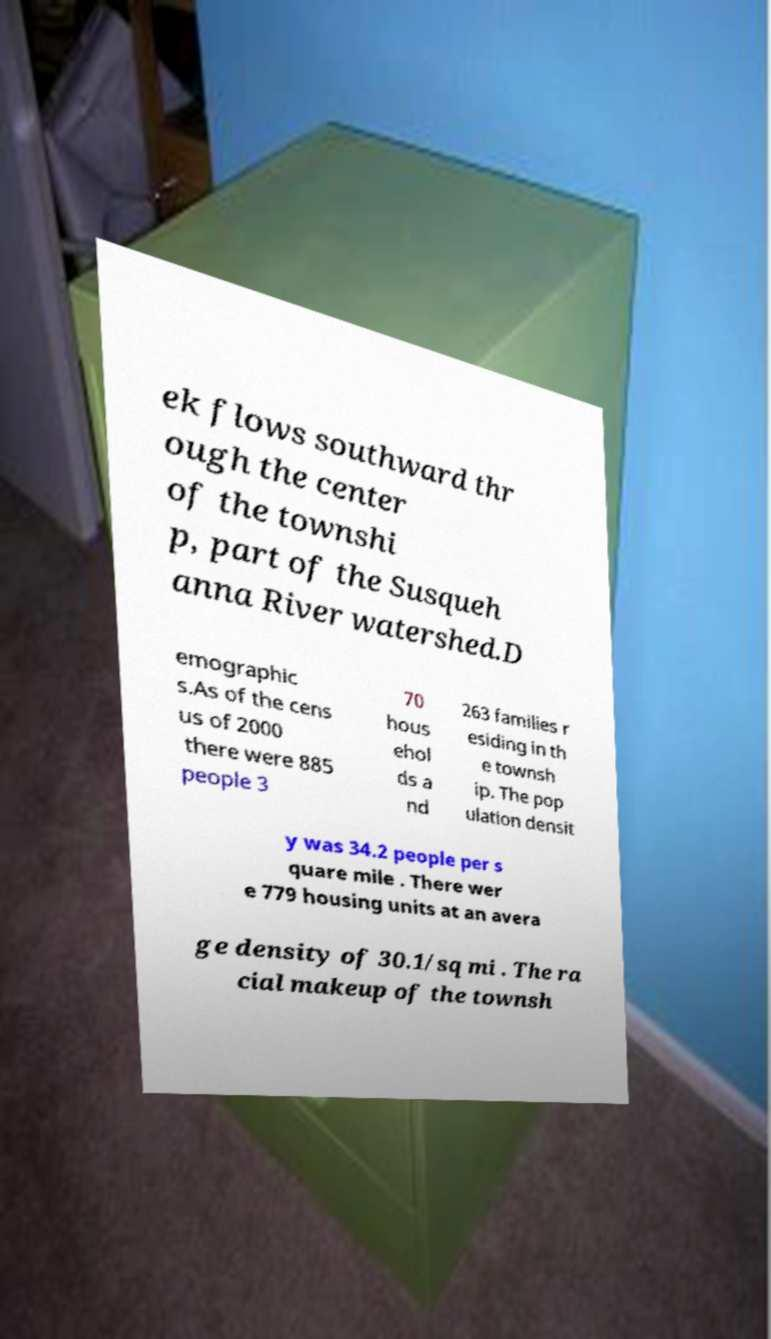Could you assist in decoding the text presented in this image and type it out clearly? ek flows southward thr ough the center of the townshi p, part of the Susqueh anna River watershed.D emographic s.As of the cens us of 2000 there were 885 people 3 70 hous ehol ds a nd 263 families r esiding in th e townsh ip. The pop ulation densit y was 34.2 people per s quare mile . There wer e 779 housing units at an avera ge density of 30.1/sq mi . The ra cial makeup of the townsh 